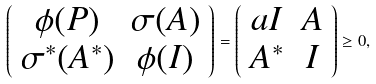Convert formula to latex. <formula><loc_0><loc_0><loc_500><loc_500>\left ( \begin{array} { c c } \phi ( P ) & \sigma ( A ) \\ \sigma ^ { * } ( A ^ { * } ) & \phi ( I ) \end{array} \right ) = \left ( \begin{array} { c c } a I & A \\ A ^ { * } & I \end{array} \right ) \geq 0 ,</formula> 